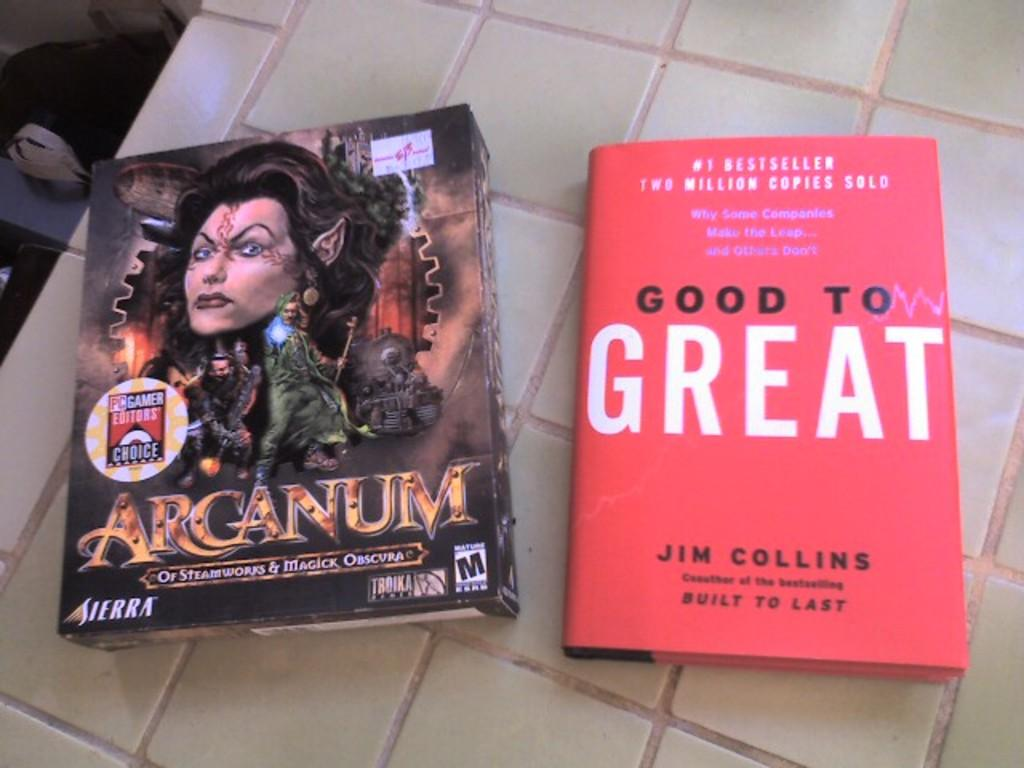<image>
Write a terse but informative summary of the picture. A book called Good to Great by Jim Collins sits on a tile floor. 